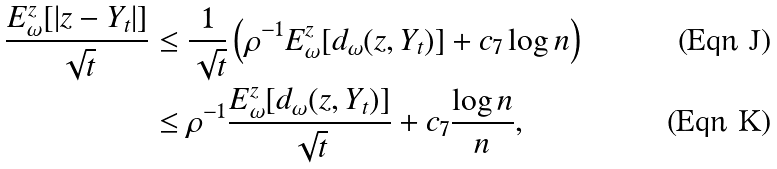<formula> <loc_0><loc_0><loc_500><loc_500>\frac { E _ { \omega } ^ { z } [ | z - Y _ { t } | ] } { \sqrt { t } } & \leq \frac { 1 } { \sqrt { t } } \left ( \rho ^ { - 1 } E _ { \omega } ^ { z } [ d _ { \omega } ( z , Y _ { t } ) ] + c _ { 7 } \log n \right ) \\ & \leq \rho ^ { - 1 } \frac { E _ { \omega } ^ { z } [ d _ { \omega } ( z , Y _ { t } ) ] } { \sqrt { t } } + c _ { 7 } \frac { \log n } { n } ,</formula> 